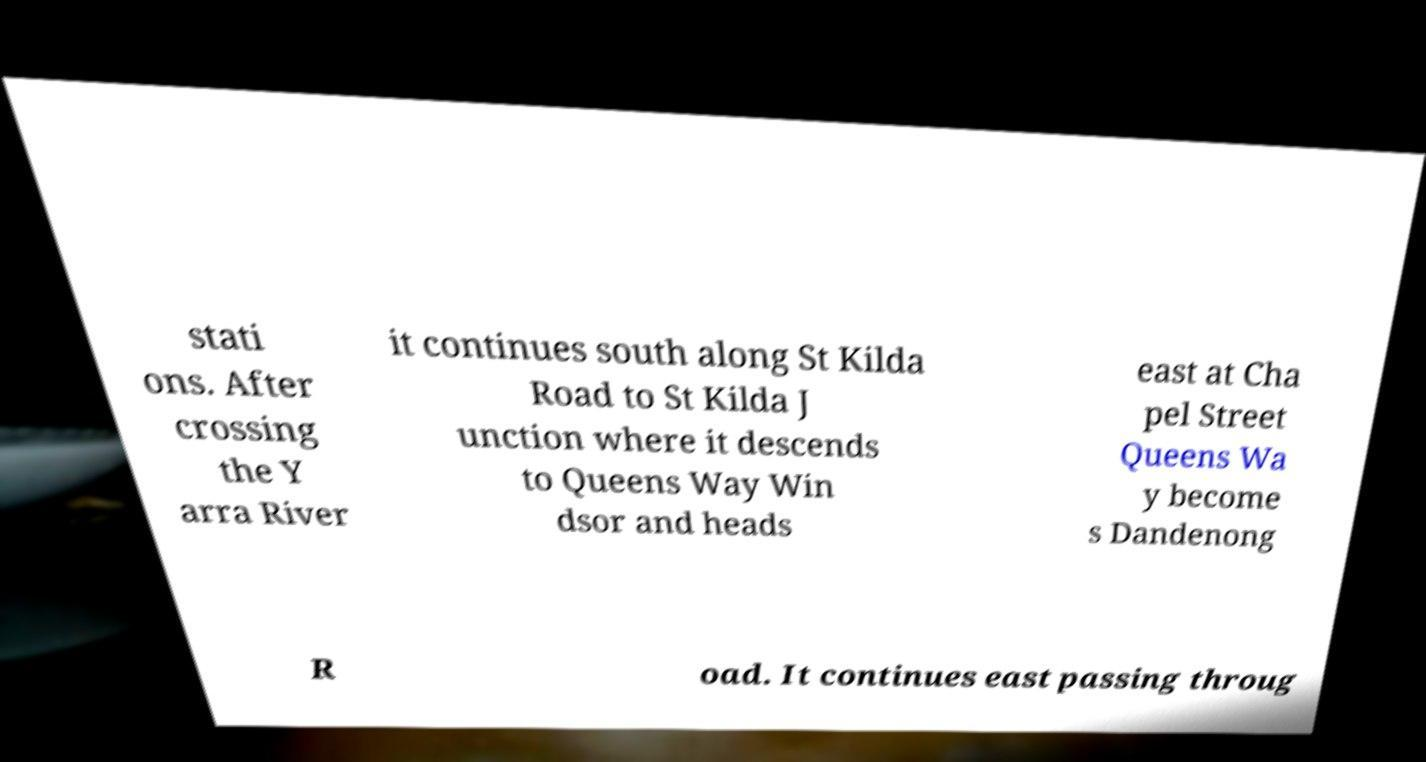Could you assist in decoding the text presented in this image and type it out clearly? stati ons. After crossing the Y arra River it continues south along St Kilda Road to St Kilda J unction where it descends to Queens Way Win dsor and heads east at Cha pel Street Queens Wa y become s Dandenong R oad. It continues east passing throug 